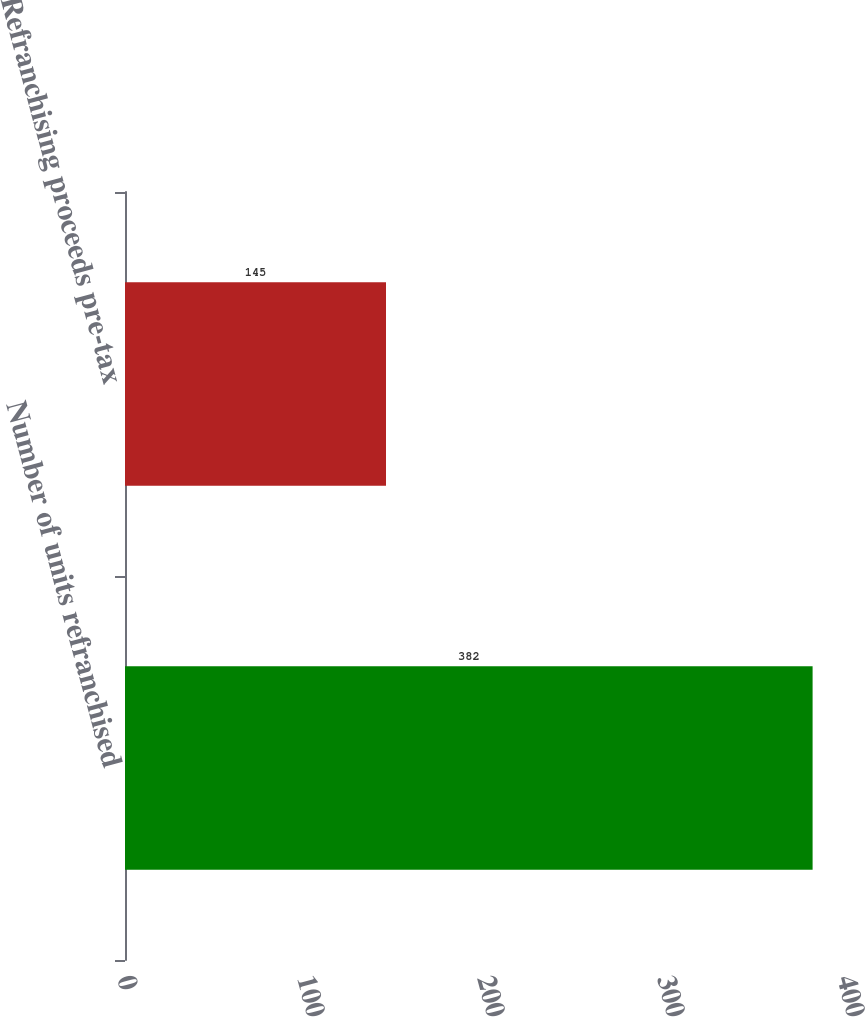<chart> <loc_0><loc_0><loc_500><loc_500><bar_chart><fcel>Number of units refranchised<fcel>Refranchising proceeds pre-tax<nl><fcel>382<fcel>145<nl></chart> 